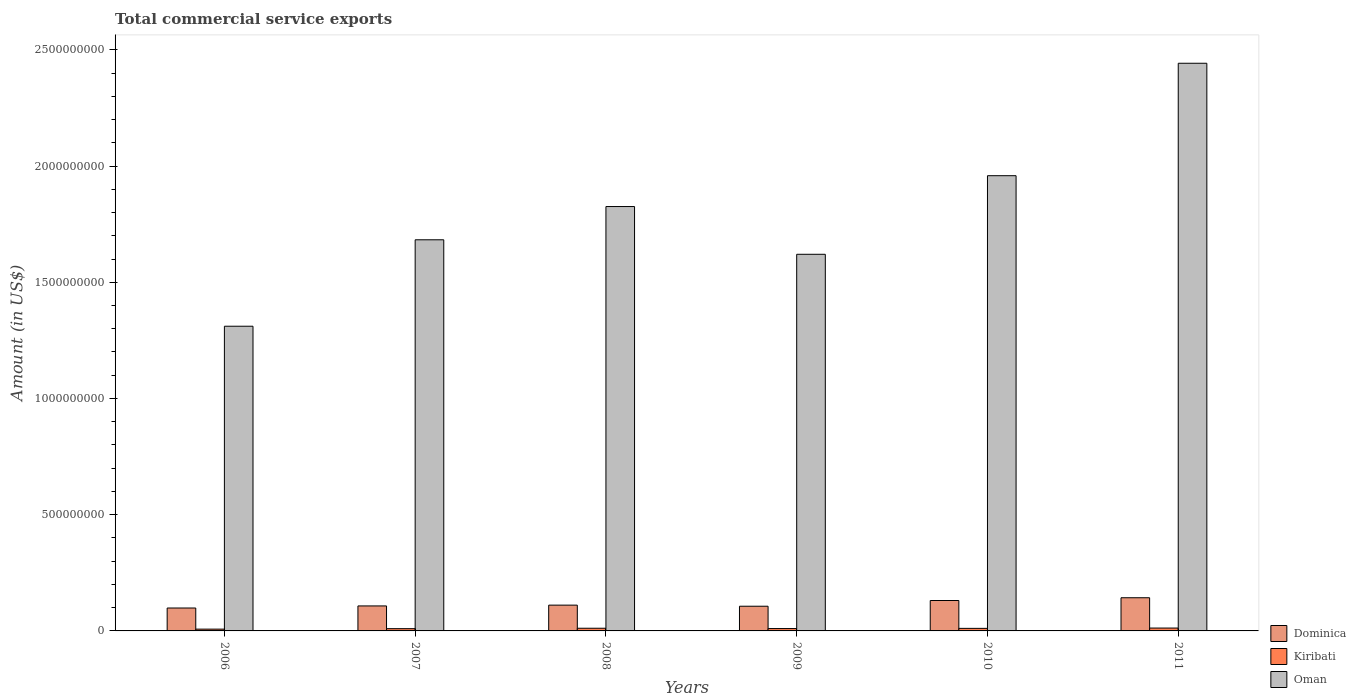Are the number of bars per tick equal to the number of legend labels?
Give a very brief answer. Yes. Are the number of bars on each tick of the X-axis equal?
Offer a terse response. Yes. What is the label of the 4th group of bars from the left?
Your answer should be compact. 2009. In how many cases, is the number of bars for a given year not equal to the number of legend labels?
Your answer should be compact. 0. What is the total commercial service exports in Dominica in 2007?
Provide a short and direct response. 1.08e+08. Across all years, what is the maximum total commercial service exports in Dominica?
Offer a terse response. 1.43e+08. Across all years, what is the minimum total commercial service exports in Oman?
Ensure brevity in your answer.  1.31e+09. In which year was the total commercial service exports in Oman minimum?
Your answer should be very brief. 2006. What is the total total commercial service exports in Kiribati in the graph?
Offer a terse response. 6.24e+07. What is the difference between the total commercial service exports in Dominica in 2007 and that in 2011?
Your answer should be very brief. -3.52e+07. What is the difference between the total commercial service exports in Dominica in 2008 and the total commercial service exports in Oman in 2010?
Offer a very short reply. -1.85e+09. What is the average total commercial service exports in Dominica per year?
Ensure brevity in your answer.  1.16e+08. In the year 2011, what is the difference between the total commercial service exports in Dominica and total commercial service exports in Kiribati?
Provide a short and direct response. 1.30e+08. What is the ratio of the total commercial service exports in Dominica in 2006 to that in 2007?
Give a very brief answer. 0.92. Is the difference between the total commercial service exports in Dominica in 2006 and 2011 greater than the difference between the total commercial service exports in Kiribati in 2006 and 2011?
Offer a terse response. No. What is the difference between the highest and the second highest total commercial service exports in Dominica?
Offer a very short reply. 1.19e+07. What is the difference between the highest and the lowest total commercial service exports in Kiribati?
Offer a terse response. 4.64e+06. Is the sum of the total commercial service exports in Kiribati in 2008 and 2009 greater than the maximum total commercial service exports in Dominica across all years?
Offer a very short reply. No. What does the 1st bar from the left in 2006 represents?
Provide a succinct answer. Dominica. What does the 3rd bar from the right in 2010 represents?
Give a very brief answer. Dominica. Does the graph contain grids?
Offer a terse response. No. Where does the legend appear in the graph?
Your answer should be very brief. Bottom right. How many legend labels are there?
Make the answer very short. 3. What is the title of the graph?
Make the answer very short. Total commercial service exports. Does "Syrian Arab Republic" appear as one of the legend labels in the graph?
Ensure brevity in your answer.  No. What is the label or title of the X-axis?
Make the answer very short. Years. What is the Amount (in US$) of Dominica in 2006?
Make the answer very short. 9.86e+07. What is the Amount (in US$) of Kiribati in 2006?
Make the answer very short. 7.67e+06. What is the Amount (in US$) of Oman in 2006?
Make the answer very short. 1.31e+09. What is the Amount (in US$) in Dominica in 2007?
Your answer should be compact. 1.08e+08. What is the Amount (in US$) of Kiribati in 2007?
Your answer should be compact. 9.73e+06. What is the Amount (in US$) in Oman in 2007?
Provide a short and direct response. 1.68e+09. What is the Amount (in US$) in Dominica in 2008?
Your response must be concise. 1.11e+08. What is the Amount (in US$) in Kiribati in 2008?
Keep it short and to the point. 1.15e+07. What is the Amount (in US$) in Oman in 2008?
Give a very brief answer. 1.83e+09. What is the Amount (in US$) in Dominica in 2009?
Make the answer very short. 1.06e+08. What is the Amount (in US$) in Kiribati in 2009?
Ensure brevity in your answer.  1.02e+07. What is the Amount (in US$) of Oman in 2009?
Offer a very short reply. 1.62e+09. What is the Amount (in US$) in Dominica in 2010?
Make the answer very short. 1.31e+08. What is the Amount (in US$) of Kiribati in 2010?
Ensure brevity in your answer.  1.10e+07. What is the Amount (in US$) in Oman in 2010?
Your answer should be very brief. 1.96e+09. What is the Amount (in US$) of Dominica in 2011?
Make the answer very short. 1.43e+08. What is the Amount (in US$) in Kiribati in 2011?
Offer a terse response. 1.23e+07. What is the Amount (in US$) in Oman in 2011?
Provide a short and direct response. 2.44e+09. Across all years, what is the maximum Amount (in US$) of Dominica?
Offer a very short reply. 1.43e+08. Across all years, what is the maximum Amount (in US$) of Kiribati?
Make the answer very short. 1.23e+07. Across all years, what is the maximum Amount (in US$) in Oman?
Keep it short and to the point. 2.44e+09. Across all years, what is the minimum Amount (in US$) in Dominica?
Provide a succinct answer. 9.86e+07. Across all years, what is the minimum Amount (in US$) of Kiribati?
Ensure brevity in your answer.  7.67e+06. Across all years, what is the minimum Amount (in US$) in Oman?
Provide a succinct answer. 1.31e+09. What is the total Amount (in US$) in Dominica in the graph?
Your answer should be very brief. 6.97e+08. What is the total Amount (in US$) in Kiribati in the graph?
Your answer should be very brief. 6.24e+07. What is the total Amount (in US$) of Oman in the graph?
Keep it short and to the point. 1.08e+1. What is the difference between the Amount (in US$) in Dominica in 2006 and that in 2007?
Your response must be concise. -8.95e+06. What is the difference between the Amount (in US$) in Kiribati in 2006 and that in 2007?
Keep it short and to the point. -2.06e+06. What is the difference between the Amount (in US$) in Oman in 2006 and that in 2007?
Keep it short and to the point. -3.72e+08. What is the difference between the Amount (in US$) in Dominica in 2006 and that in 2008?
Ensure brevity in your answer.  -1.23e+07. What is the difference between the Amount (in US$) in Kiribati in 2006 and that in 2008?
Your answer should be compact. -3.88e+06. What is the difference between the Amount (in US$) in Oman in 2006 and that in 2008?
Make the answer very short. -5.15e+08. What is the difference between the Amount (in US$) of Dominica in 2006 and that in 2009?
Offer a terse response. -7.62e+06. What is the difference between the Amount (in US$) in Kiribati in 2006 and that in 2009?
Give a very brief answer. -2.49e+06. What is the difference between the Amount (in US$) of Oman in 2006 and that in 2009?
Offer a very short reply. -3.09e+08. What is the difference between the Amount (in US$) of Dominica in 2006 and that in 2010?
Your response must be concise. -3.22e+07. What is the difference between the Amount (in US$) in Kiribati in 2006 and that in 2010?
Provide a succinct answer. -3.31e+06. What is the difference between the Amount (in US$) of Oman in 2006 and that in 2010?
Offer a very short reply. -6.48e+08. What is the difference between the Amount (in US$) of Dominica in 2006 and that in 2011?
Provide a short and direct response. -4.41e+07. What is the difference between the Amount (in US$) in Kiribati in 2006 and that in 2011?
Give a very brief answer. -4.64e+06. What is the difference between the Amount (in US$) in Oman in 2006 and that in 2011?
Provide a succinct answer. -1.13e+09. What is the difference between the Amount (in US$) of Dominica in 2007 and that in 2008?
Your answer should be compact. -3.38e+06. What is the difference between the Amount (in US$) in Kiribati in 2007 and that in 2008?
Give a very brief answer. -1.81e+06. What is the difference between the Amount (in US$) of Oman in 2007 and that in 2008?
Your answer should be compact. -1.43e+08. What is the difference between the Amount (in US$) in Dominica in 2007 and that in 2009?
Provide a short and direct response. 1.33e+06. What is the difference between the Amount (in US$) in Kiribati in 2007 and that in 2009?
Give a very brief answer. -4.25e+05. What is the difference between the Amount (in US$) of Oman in 2007 and that in 2009?
Your answer should be very brief. 6.24e+07. What is the difference between the Amount (in US$) in Dominica in 2007 and that in 2010?
Provide a short and direct response. -2.33e+07. What is the difference between the Amount (in US$) of Kiribati in 2007 and that in 2010?
Provide a succinct answer. -1.25e+06. What is the difference between the Amount (in US$) in Oman in 2007 and that in 2010?
Your answer should be compact. -2.76e+08. What is the difference between the Amount (in US$) of Dominica in 2007 and that in 2011?
Your answer should be very brief. -3.52e+07. What is the difference between the Amount (in US$) of Kiribati in 2007 and that in 2011?
Keep it short and to the point. -2.57e+06. What is the difference between the Amount (in US$) of Oman in 2007 and that in 2011?
Your response must be concise. -7.59e+08. What is the difference between the Amount (in US$) in Dominica in 2008 and that in 2009?
Your answer should be compact. 4.71e+06. What is the difference between the Amount (in US$) in Kiribati in 2008 and that in 2009?
Give a very brief answer. 1.39e+06. What is the difference between the Amount (in US$) in Oman in 2008 and that in 2009?
Keep it short and to the point. 2.05e+08. What is the difference between the Amount (in US$) in Dominica in 2008 and that in 2010?
Offer a very short reply. -1.99e+07. What is the difference between the Amount (in US$) in Kiribati in 2008 and that in 2010?
Offer a terse response. 5.66e+05. What is the difference between the Amount (in US$) of Oman in 2008 and that in 2010?
Ensure brevity in your answer.  -1.33e+08. What is the difference between the Amount (in US$) in Dominica in 2008 and that in 2011?
Ensure brevity in your answer.  -3.18e+07. What is the difference between the Amount (in US$) in Kiribati in 2008 and that in 2011?
Give a very brief answer. -7.62e+05. What is the difference between the Amount (in US$) of Oman in 2008 and that in 2011?
Give a very brief answer. -6.16e+08. What is the difference between the Amount (in US$) in Dominica in 2009 and that in 2010?
Provide a short and direct response. -2.46e+07. What is the difference between the Amount (in US$) of Kiribati in 2009 and that in 2010?
Your answer should be compact. -8.21e+05. What is the difference between the Amount (in US$) in Oman in 2009 and that in 2010?
Offer a terse response. -3.38e+08. What is the difference between the Amount (in US$) of Dominica in 2009 and that in 2011?
Ensure brevity in your answer.  -3.65e+07. What is the difference between the Amount (in US$) of Kiribati in 2009 and that in 2011?
Offer a terse response. -2.15e+06. What is the difference between the Amount (in US$) of Oman in 2009 and that in 2011?
Provide a short and direct response. -8.22e+08. What is the difference between the Amount (in US$) of Dominica in 2010 and that in 2011?
Make the answer very short. -1.19e+07. What is the difference between the Amount (in US$) in Kiribati in 2010 and that in 2011?
Make the answer very short. -1.33e+06. What is the difference between the Amount (in US$) of Oman in 2010 and that in 2011?
Your response must be concise. -4.84e+08. What is the difference between the Amount (in US$) of Dominica in 2006 and the Amount (in US$) of Kiribati in 2007?
Your response must be concise. 8.89e+07. What is the difference between the Amount (in US$) in Dominica in 2006 and the Amount (in US$) in Oman in 2007?
Give a very brief answer. -1.58e+09. What is the difference between the Amount (in US$) of Kiribati in 2006 and the Amount (in US$) of Oman in 2007?
Offer a very short reply. -1.68e+09. What is the difference between the Amount (in US$) of Dominica in 2006 and the Amount (in US$) of Kiribati in 2008?
Offer a terse response. 8.71e+07. What is the difference between the Amount (in US$) in Dominica in 2006 and the Amount (in US$) in Oman in 2008?
Ensure brevity in your answer.  -1.73e+09. What is the difference between the Amount (in US$) in Kiribati in 2006 and the Amount (in US$) in Oman in 2008?
Make the answer very short. -1.82e+09. What is the difference between the Amount (in US$) of Dominica in 2006 and the Amount (in US$) of Kiribati in 2009?
Your response must be concise. 8.84e+07. What is the difference between the Amount (in US$) of Dominica in 2006 and the Amount (in US$) of Oman in 2009?
Give a very brief answer. -1.52e+09. What is the difference between the Amount (in US$) of Kiribati in 2006 and the Amount (in US$) of Oman in 2009?
Your answer should be very brief. -1.61e+09. What is the difference between the Amount (in US$) of Dominica in 2006 and the Amount (in US$) of Kiribati in 2010?
Keep it short and to the point. 8.76e+07. What is the difference between the Amount (in US$) in Dominica in 2006 and the Amount (in US$) in Oman in 2010?
Your answer should be very brief. -1.86e+09. What is the difference between the Amount (in US$) in Kiribati in 2006 and the Amount (in US$) in Oman in 2010?
Give a very brief answer. -1.95e+09. What is the difference between the Amount (in US$) in Dominica in 2006 and the Amount (in US$) in Kiribati in 2011?
Keep it short and to the point. 8.63e+07. What is the difference between the Amount (in US$) in Dominica in 2006 and the Amount (in US$) in Oman in 2011?
Provide a succinct answer. -2.34e+09. What is the difference between the Amount (in US$) in Kiribati in 2006 and the Amount (in US$) in Oman in 2011?
Your answer should be compact. -2.43e+09. What is the difference between the Amount (in US$) in Dominica in 2007 and the Amount (in US$) in Kiribati in 2008?
Provide a short and direct response. 9.60e+07. What is the difference between the Amount (in US$) in Dominica in 2007 and the Amount (in US$) in Oman in 2008?
Your answer should be very brief. -1.72e+09. What is the difference between the Amount (in US$) in Kiribati in 2007 and the Amount (in US$) in Oman in 2008?
Offer a terse response. -1.82e+09. What is the difference between the Amount (in US$) of Dominica in 2007 and the Amount (in US$) of Kiribati in 2009?
Offer a terse response. 9.74e+07. What is the difference between the Amount (in US$) in Dominica in 2007 and the Amount (in US$) in Oman in 2009?
Your answer should be very brief. -1.51e+09. What is the difference between the Amount (in US$) of Kiribati in 2007 and the Amount (in US$) of Oman in 2009?
Your answer should be very brief. -1.61e+09. What is the difference between the Amount (in US$) in Dominica in 2007 and the Amount (in US$) in Kiribati in 2010?
Provide a short and direct response. 9.66e+07. What is the difference between the Amount (in US$) in Dominica in 2007 and the Amount (in US$) in Oman in 2010?
Keep it short and to the point. -1.85e+09. What is the difference between the Amount (in US$) of Kiribati in 2007 and the Amount (in US$) of Oman in 2010?
Offer a terse response. -1.95e+09. What is the difference between the Amount (in US$) in Dominica in 2007 and the Amount (in US$) in Kiribati in 2011?
Your answer should be very brief. 9.52e+07. What is the difference between the Amount (in US$) of Dominica in 2007 and the Amount (in US$) of Oman in 2011?
Your response must be concise. -2.33e+09. What is the difference between the Amount (in US$) in Kiribati in 2007 and the Amount (in US$) in Oman in 2011?
Keep it short and to the point. -2.43e+09. What is the difference between the Amount (in US$) in Dominica in 2008 and the Amount (in US$) in Kiribati in 2009?
Keep it short and to the point. 1.01e+08. What is the difference between the Amount (in US$) in Dominica in 2008 and the Amount (in US$) in Oman in 2009?
Make the answer very short. -1.51e+09. What is the difference between the Amount (in US$) of Kiribati in 2008 and the Amount (in US$) of Oman in 2009?
Give a very brief answer. -1.61e+09. What is the difference between the Amount (in US$) in Dominica in 2008 and the Amount (in US$) in Kiribati in 2010?
Offer a very short reply. 9.99e+07. What is the difference between the Amount (in US$) in Dominica in 2008 and the Amount (in US$) in Oman in 2010?
Make the answer very short. -1.85e+09. What is the difference between the Amount (in US$) of Kiribati in 2008 and the Amount (in US$) of Oman in 2010?
Give a very brief answer. -1.95e+09. What is the difference between the Amount (in US$) of Dominica in 2008 and the Amount (in US$) of Kiribati in 2011?
Your answer should be very brief. 9.86e+07. What is the difference between the Amount (in US$) in Dominica in 2008 and the Amount (in US$) in Oman in 2011?
Ensure brevity in your answer.  -2.33e+09. What is the difference between the Amount (in US$) in Kiribati in 2008 and the Amount (in US$) in Oman in 2011?
Your response must be concise. -2.43e+09. What is the difference between the Amount (in US$) in Dominica in 2009 and the Amount (in US$) in Kiribati in 2010?
Ensure brevity in your answer.  9.52e+07. What is the difference between the Amount (in US$) in Dominica in 2009 and the Amount (in US$) in Oman in 2010?
Keep it short and to the point. -1.85e+09. What is the difference between the Amount (in US$) in Kiribati in 2009 and the Amount (in US$) in Oman in 2010?
Make the answer very short. -1.95e+09. What is the difference between the Amount (in US$) in Dominica in 2009 and the Amount (in US$) in Kiribati in 2011?
Ensure brevity in your answer.  9.39e+07. What is the difference between the Amount (in US$) in Dominica in 2009 and the Amount (in US$) in Oman in 2011?
Offer a very short reply. -2.34e+09. What is the difference between the Amount (in US$) in Kiribati in 2009 and the Amount (in US$) in Oman in 2011?
Provide a short and direct response. -2.43e+09. What is the difference between the Amount (in US$) of Dominica in 2010 and the Amount (in US$) of Kiribati in 2011?
Provide a succinct answer. 1.19e+08. What is the difference between the Amount (in US$) of Dominica in 2010 and the Amount (in US$) of Oman in 2011?
Give a very brief answer. -2.31e+09. What is the difference between the Amount (in US$) in Kiribati in 2010 and the Amount (in US$) in Oman in 2011?
Offer a very short reply. -2.43e+09. What is the average Amount (in US$) in Dominica per year?
Your answer should be compact. 1.16e+08. What is the average Amount (in US$) of Kiribati per year?
Offer a very short reply. 1.04e+07. What is the average Amount (in US$) of Oman per year?
Make the answer very short. 1.81e+09. In the year 2006, what is the difference between the Amount (in US$) in Dominica and Amount (in US$) in Kiribati?
Keep it short and to the point. 9.09e+07. In the year 2006, what is the difference between the Amount (in US$) in Dominica and Amount (in US$) in Oman?
Keep it short and to the point. -1.21e+09. In the year 2006, what is the difference between the Amount (in US$) of Kiribati and Amount (in US$) of Oman?
Keep it short and to the point. -1.30e+09. In the year 2007, what is the difference between the Amount (in US$) of Dominica and Amount (in US$) of Kiribati?
Your response must be concise. 9.78e+07. In the year 2007, what is the difference between the Amount (in US$) in Dominica and Amount (in US$) in Oman?
Ensure brevity in your answer.  -1.58e+09. In the year 2007, what is the difference between the Amount (in US$) in Kiribati and Amount (in US$) in Oman?
Provide a short and direct response. -1.67e+09. In the year 2008, what is the difference between the Amount (in US$) in Dominica and Amount (in US$) in Kiribati?
Ensure brevity in your answer.  9.94e+07. In the year 2008, what is the difference between the Amount (in US$) in Dominica and Amount (in US$) in Oman?
Give a very brief answer. -1.71e+09. In the year 2008, what is the difference between the Amount (in US$) of Kiribati and Amount (in US$) of Oman?
Provide a succinct answer. -1.81e+09. In the year 2009, what is the difference between the Amount (in US$) of Dominica and Amount (in US$) of Kiribati?
Your answer should be compact. 9.61e+07. In the year 2009, what is the difference between the Amount (in US$) in Dominica and Amount (in US$) in Oman?
Give a very brief answer. -1.51e+09. In the year 2009, what is the difference between the Amount (in US$) in Kiribati and Amount (in US$) in Oman?
Your response must be concise. -1.61e+09. In the year 2010, what is the difference between the Amount (in US$) in Dominica and Amount (in US$) in Kiribati?
Keep it short and to the point. 1.20e+08. In the year 2010, what is the difference between the Amount (in US$) of Dominica and Amount (in US$) of Oman?
Ensure brevity in your answer.  -1.83e+09. In the year 2010, what is the difference between the Amount (in US$) of Kiribati and Amount (in US$) of Oman?
Keep it short and to the point. -1.95e+09. In the year 2011, what is the difference between the Amount (in US$) in Dominica and Amount (in US$) in Kiribati?
Keep it short and to the point. 1.30e+08. In the year 2011, what is the difference between the Amount (in US$) of Dominica and Amount (in US$) of Oman?
Give a very brief answer. -2.30e+09. In the year 2011, what is the difference between the Amount (in US$) of Kiribati and Amount (in US$) of Oman?
Offer a very short reply. -2.43e+09. What is the ratio of the Amount (in US$) of Dominica in 2006 to that in 2007?
Offer a terse response. 0.92. What is the ratio of the Amount (in US$) of Kiribati in 2006 to that in 2007?
Ensure brevity in your answer.  0.79. What is the ratio of the Amount (in US$) in Oman in 2006 to that in 2007?
Ensure brevity in your answer.  0.78. What is the ratio of the Amount (in US$) of Kiribati in 2006 to that in 2008?
Offer a terse response. 0.66. What is the ratio of the Amount (in US$) of Oman in 2006 to that in 2008?
Offer a terse response. 0.72. What is the ratio of the Amount (in US$) of Dominica in 2006 to that in 2009?
Offer a very short reply. 0.93. What is the ratio of the Amount (in US$) in Kiribati in 2006 to that in 2009?
Provide a short and direct response. 0.75. What is the ratio of the Amount (in US$) of Oman in 2006 to that in 2009?
Your response must be concise. 0.81. What is the ratio of the Amount (in US$) of Dominica in 2006 to that in 2010?
Give a very brief answer. 0.75. What is the ratio of the Amount (in US$) of Kiribati in 2006 to that in 2010?
Your response must be concise. 0.7. What is the ratio of the Amount (in US$) of Oman in 2006 to that in 2010?
Provide a short and direct response. 0.67. What is the ratio of the Amount (in US$) in Dominica in 2006 to that in 2011?
Keep it short and to the point. 0.69. What is the ratio of the Amount (in US$) of Kiribati in 2006 to that in 2011?
Make the answer very short. 0.62. What is the ratio of the Amount (in US$) in Oman in 2006 to that in 2011?
Offer a very short reply. 0.54. What is the ratio of the Amount (in US$) in Dominica in 2007 to that in 2008?
Keep it short and to the point. 0.97. What is the ratio of the Amount (in US$) in Kiribati in 2007 to that in 2008?
Offer a very short reply. 0.84. What is the ratio of the Amount (in US$) of Oman in 2007 to that in 2008?
Provide a succinct answer. 0.92. What is the ratio of the Amount (in US$) of Dominica in 2007 to that in 2009?
Provide a succinct answer. 1.01. What is the ratio of the Amount (in US$) of Kiribati in 2007 to that in 2009?
Your answer should be very brief. 0.96. What is the ratio of the Amount (in US$) of Dominica in 2007 to that in 2010?
Your answer should be compact. 0.82. What is the ratio of the Amount (in US$) of Kiribati in 2007 to that in 2010?
Give a very brief answer. 0.89. What is the ratio of the Amount (in US$) of Oman in 2007 to that in 2010?
Offer a very short reply. 0.86. What is the ratio of the Amount (in US$) of Dominica in 2007 to that in 2011?
Provide a short and direct response. 0.75. What is the ratio of the Amount (in US$) in Kiribati in 2007 to that in 2011?
Give a very brief answer. 0.79. What is the ratio of the Amount (in US$) of Oman in 2007 to that in 2011?
Give a very brief answer. 0.69. What is the ratio of the Amount (in US$) of Dominica in 2008 to that in 2009?
Make the answer very short. 1.04. What is the ratio of the Amount (in US$) of Kiribati in 2008 to that in 2009?
Your response must be concise. 1.14. What is the ratio of the Amount (in US$) of Oman in 2008 to that in 2009?
Make the answer very short. 1.13. What is the ratio of the Amount (in US$) in Dominica in 2008 to that in 2010?
Ensure brevity in your answer.  0.85. What is the ratio of the Amount (in US$) in Kiribati in 2008 to that in 2010?
Your answer should be very brief. 1.05. What is the ratio of the Amount (in US$) of Oman in 2008 to that in 2010?
Provide a short and direct response. 0.93. What is the ratio of the Amount (in US$) of Dominica in 2008 to that in 2011?
Keep it short and to the point. 0.78. What is the ratio of the Amount (in US$) in Kiribati in 2008 to that in 2011?
Make the answer very short. 0.94. What is the ratio of the Amount (in US$) in Oman in 2008 to that in 2011?
Offer a terse response. 0.75. What is the ratio of the Amount (in US$) of Dominica in 2009 to that in 2010?
Ensure brevity in your answer.  0.81. What is the ratio of the Amount (in US$) of Kiribati in 2009 to that in 2010?
Make the answer very short. 0.93. What is the ratio of the Amount (in US$) of Oman in 2009 to that in 2010?
Offer a very short reply. 0.83. What is the ratio of the Amount (in US$) of Dominica in 2009 to that in 2011?
Offer a very short reply. 0.74. What is the ratio of the Amount (in US$) in Kiribati in 2009 to that in 2011?
Keep it short and to the point. 0.83. What is the ratio of the Amount (in US$) in Oman in 2009 to that in 2011?
Provide a short and direct response. 0.66. What is the ratio of the Amount (in US$) of Dominica in 2010 to that in 2011?
Give a very brief answer. 0.92. What is the ratio of the Amount (in US$) in Kiribati in 2010 to that in 2011?
Your response must be concise. 0.89. What is the ratio of the Amount (in US$) of Oman in 2010 to that in 2011?
Give a very brief answer. 0.8. What is the difference between the highest and the second highest Amount (in US$) in Dominica?
Give a very brief answer. 1.19e+07. What is the difference between the highest and the second highest Amount (in US$) in Kiribati?
Provide a succinct answer. 7.62e+05. What is the difference between the highest and the second highest Amount (in US$) in Oman?
Your answer should be very brief. 4.84e+08. What is the difference between the highest and the lowest Amount (in US$) of Dominica?
Make the answer very short. 4.41e+07. What is the difference between the highest and the lowest Amount (in US$) of Kiribati?
Offer a very short reply. 4.64e+06. What is the difference between the highest and the lowest Amount (in US$) of Oman?
Your answer should be compact. 1.13e+09. 